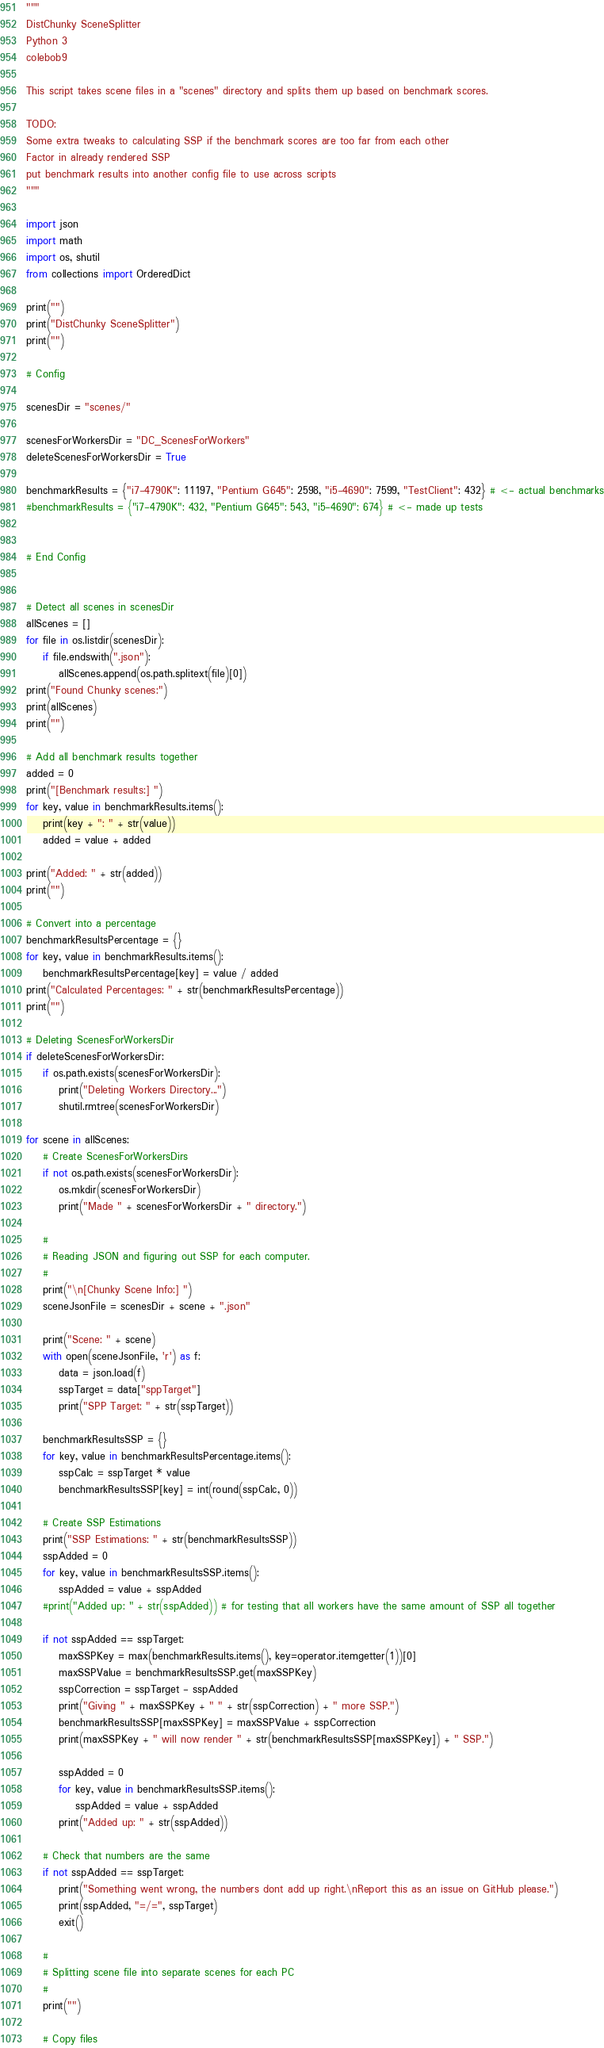<code> <loc_0><loc_0><loc_500><loc_500><_Python_>"""
DistChunky SceneSplitter
Python 3
colebob9

This script takes scene files in a "scenes" directory and splits them up based on benchmark scores.

TODO:
Some extra tweaks to calculating SSP if the benchmark scores are too far from each other
Factor in already rendered SSP
put benchmark results into another config file to use across scripts
"""

import json
import math
import os, shutil
from collections import OrderedDict

print("")
print("DistChunky SceneSplitter")
print("")

# Config

scenesDir = "scenes/"

scenesForWorkersDir = "DC_ScenesForWorkers"
deleteScenesForWorkersDir = True

benchmarkResults = {"i7-4790K": 11197, "Pentium G645": 2598, "i5-4690": 7599, "TestClient": 432} # <- actual benchmarks
#benchmarkResults = {"i7-4790K": 432, "Pentium G645": 543, "i5-4690": 674} # <- made up tests


# End Config


# Detect all scenes in scenesDir
allScenes = []
for file in os.listdir(scenesDir):
    if file.endswith(".json"):
        allScenes.append(os.path.splitext(file)[0])
print("Found Chunky scenes:")
print(allScenes)
print("")

# Add all benchmark results together
added = 0
print("[Benchmark results:] ")
for key, value in benchmarkResults.items():
    print(key + ": " + str(value))
    added = value + added
    
print("Added: " + str(added))
print("")

# Convert into a percentage
benchmarkResultsPercentage = {}
for key, value in benchmarkResults.items():
    benchmarkResultsPercentage[key] = value / added
print("Calculated Percentages: " + str(benchmarkResultsPercentage))
print("")

# Deleting ScenesForWorkersDir
if deleteScenesForWorkersDir:
    if os.path.exists(scenesForWorkersDir):
        print("Deleting Workers Directory...")
        shutil.rmtree(scenesForWorkersDir)

for scene in allScenes:
    # Create ScenesForWorkersDirs
    if not os.path.exists(scenesForWorkersDir):
        os.mkdir(scenesForWorkersDir)
        print("Made " + scenesForWorkersDir + " directory.")

    #
    # Reading JSON and figuring out SSP for each computer.
    #
    print("\n[Chunky Scene Info:] ")
    sceneJsonFile = scenesDir + scene + ".json"

    print("Scene: " + scene)
    with open(sceneJsonFile, 'r') as f:
        data = json.load(f)
        sspTarget = data["sppTarget"]
        print("SPP Target: " + str(sspTarget))

    benchmarkResultsSSP = {}
    for key, value in benchmarkResultsPercentage.items():
        sspCalc = sspTarget * value
        benchmarkResultsSSP[key] = int(round(sspCalc, 0))
        
    # Create SSP Estimations
    print("SSP Estimations: " + str(benchmarkResultsSSP))
    sspAdded = 0
    for key, value in benchmarkResultsSSP.items():
        sspAdded = value + sspAdded
    #print("Added up: " + str(sspAdded)) # for testing that all workers have the same amount of SSP all together

    if not sspAdded == sspTarget:
        maxSSPKey = max(benchmarkResults.items(), key=operator.itemgetter(1))[0]
        maxSSPValue = benchmarkResultsSSP.get(maxSSPKey)
        sspCorrection = sspTarget - sspAdded
        print("Giving " + maxSSPKey + " " + str(sspCorrection) + " more SSP.")
        benchmarkResultsSSP[maxSSPKey] = maxSSPValue + sspCorrection
        print(maxSSPKey + " will now render " + str(benchmarkResultsSSP[maxSSPKey]) + " SSP.")
        
        sspAdded = 0
        for key, value in benchmarkResultsSSP.items():
            sspAdded = value + sspAdded
        print("Added up: " + str(sspAdded))
        
    # Check that numbers are the same
    if not sspAdded == sspTarget:
        print("Something went wrong, the numbers dont add up right.\nReport this as an issue on GitHub please.")
        print(sspAdded, "=/=", sspTarget)
        exit()
        
    #
    # Splitting scene file into separate scenes for each PC
    #
    print("")

    # Copy files
</code> 